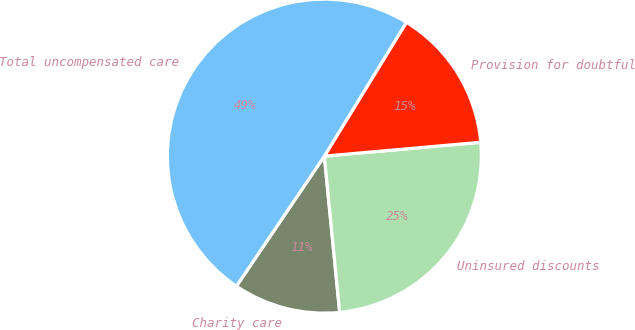Convert chart to OTSL. <chart><loc_0><loc_0><loc_500><loc_500><pie_chart><fcel>Charity care<fcel>Uninsured discounts<fcel>Provision for doubtful<fcel>Total uncompensated care<nl><fcel>11.02%<fcel>24.85%<fcel>14.84%<fcel>49.29%<nl></chart> 